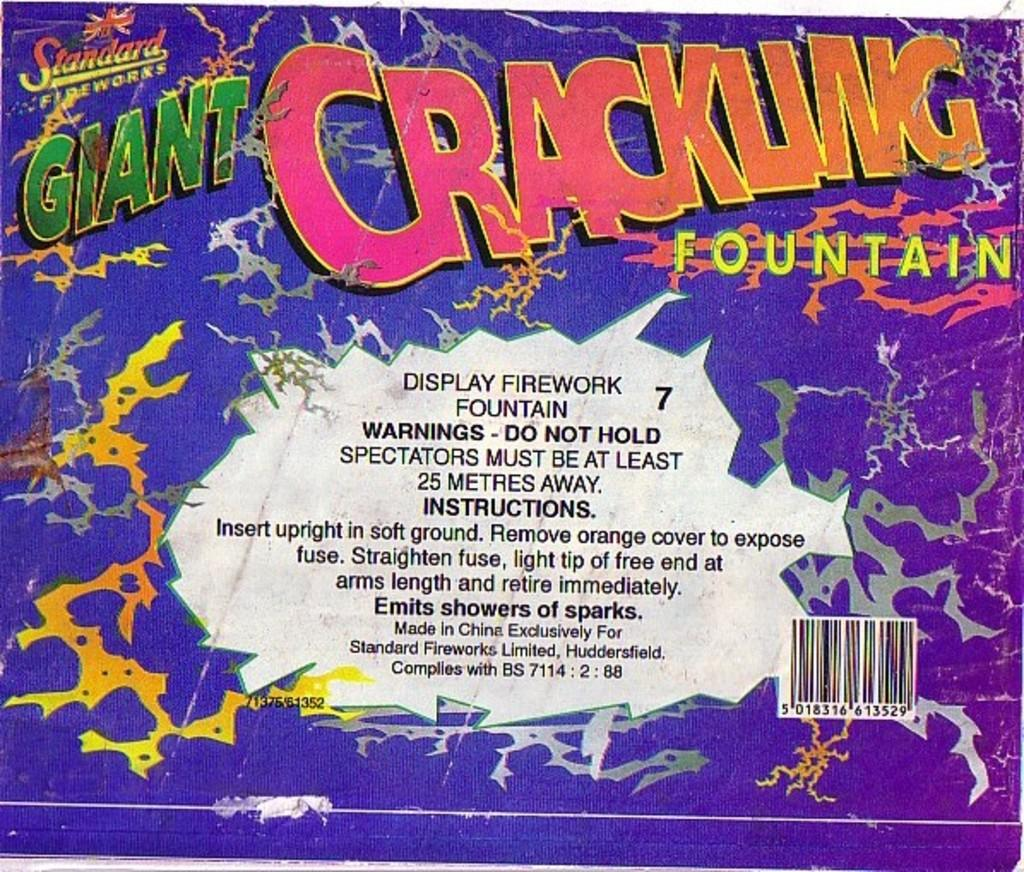<image>
Render a clear and concise summary of the photo. The firework packaging displayed a lot of useful information. 